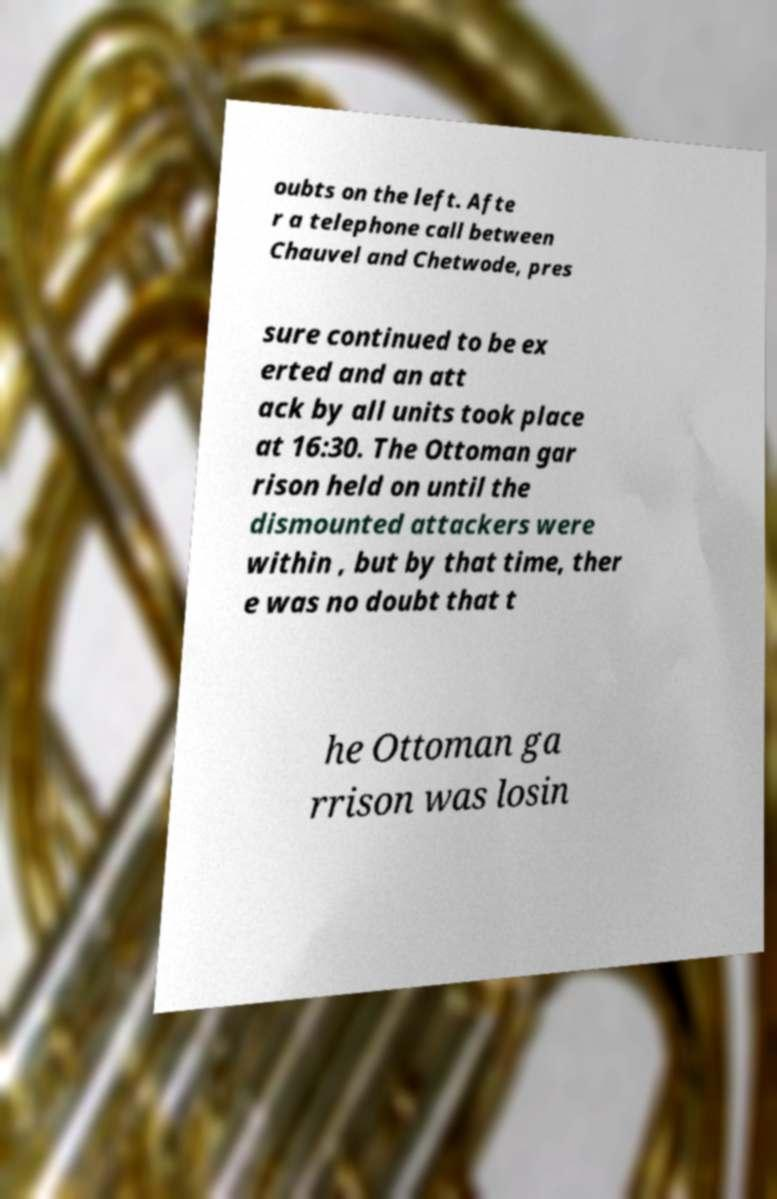What messages or text are displayed in this image? I need them in a readable, typed format. oubts on the left. Afte r a telephone call between Chauvel and Chetwode, pres sure continued to be ex erted and an att ack by all units took place at 16:30. The Ottoman gar rison held on until the dismounted attackers were within , but by that time, ther e was no doubt that t he Ottoman ga rrison was losin 